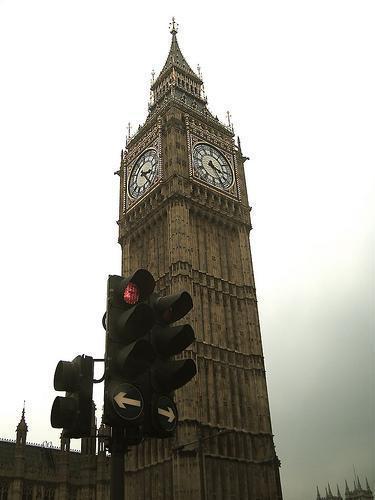How many clocks are in the photo?
Give a very brief answer. 2. 